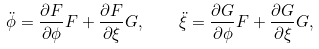<formula> <loc_0><loc_0><loc_500><loc_500>\ddot { \phi } = \frac { \partial F } { \partial \phi } F + \frac { \partial F } { \partial \xi } G , \quad \ddot { \xi } = \frac { \partial G } { \partial \phi } F + \frac { \partial G } { \partial \xi } G ,</formula> 